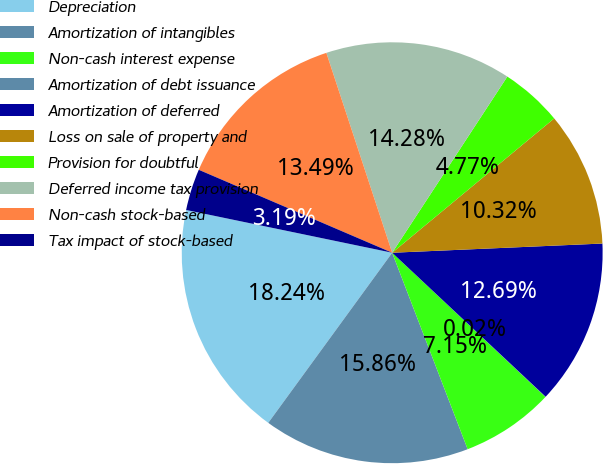Convert chart. <chart><loc_0><loc_0><loc_500><loc_500><pie_chart><fcel>Depreciation<fcel>Amortization of intangibles<fcel>Non-cash interest expense<fcel>Amortization of debt issuance<fcel>Amortization of deferred<fcel>Loss on sale of property and<fcel>Provision for doubtful<fcel>Deferred income tax provision<fcel>Non-cash stock-based<fcel>Tax impact of stock-based<nl><fcel>18.24%<fcel>15.86%<fcel>7.15%<fcel>0.02%<fcel>12.69%<fcel>10.32%<fcel>4.77%<fcel>14.28%<fcel>13.49%<fcel>3.19%<nl></chart> 